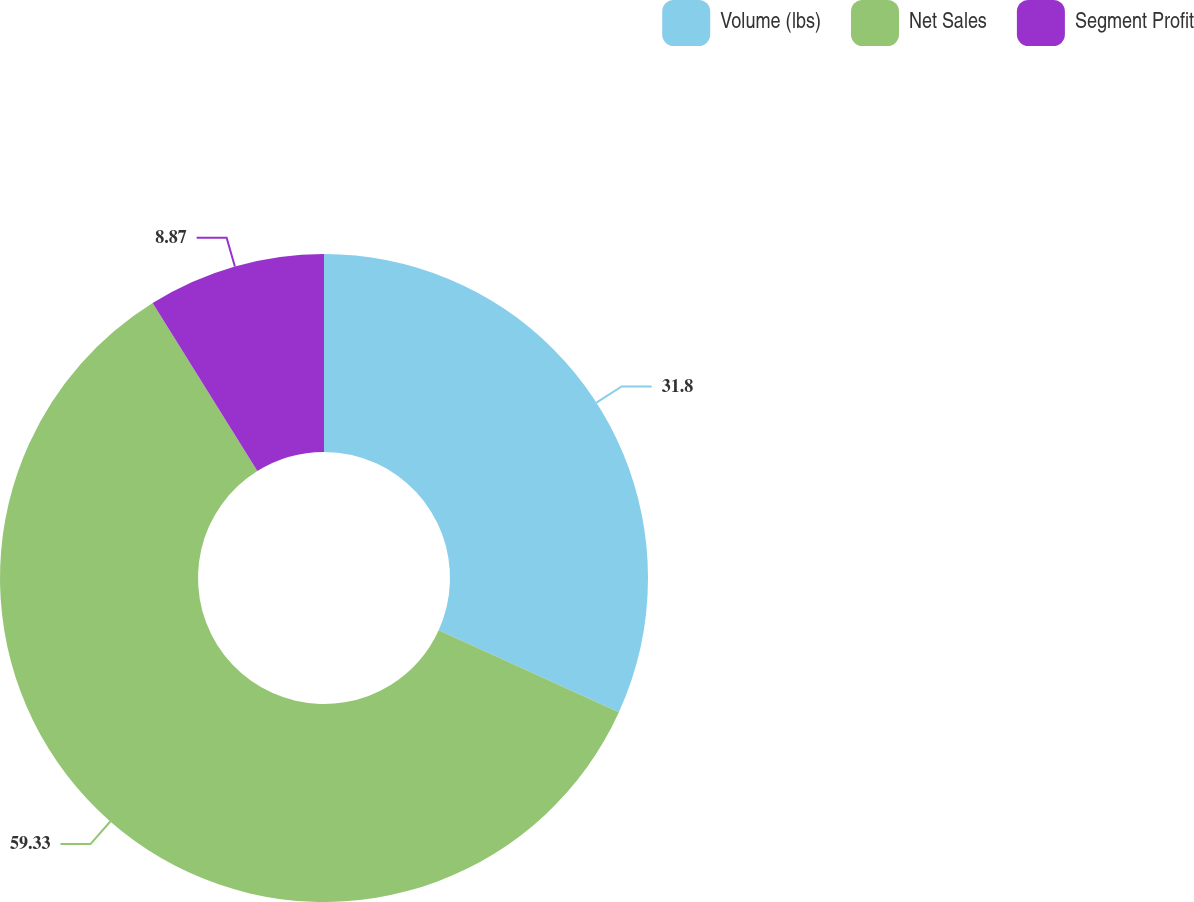Convert chart to OTSL. <chart><loc_0><loc_0><loc_500><loc_500><pie_chart><fcel>Volume (lbs)<fcel>Net Sales<fcel>Segment Profit<nl><fcel>31.8%<fcel>59.33%<fcel>8.87%<nl></chart> 